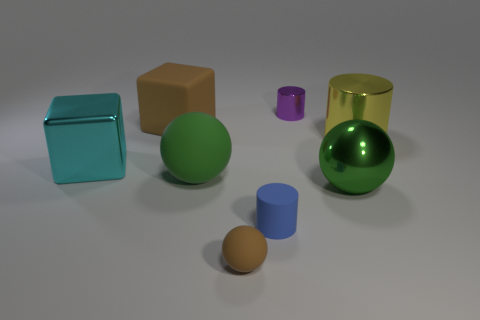Add 1 purple objects. How many objects exist? 9 Subtract all cubes. How many objects are left? 6 Subtract 0 yellow blocks. How many objects are left? 8 Subtract all small spheres. Subtract all tiny brown rubber spheres. How many objects are left? 6 Add 6 big rubber blocks. How many big rubber blocks are left? 7 Add 3 purple metal cylinders. How many purple metal cylinders exist? 4 